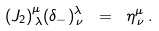<formula> <loc_0><loc_0><loc_500><loc_500>( J _ { 2 } ) ^ { \mu } _ { \, \lambda } ( \delta _ { - } ) ^ { \lambda } _ { \, \nu } \ = \ \eta ^ { \mu } _ { \, \nu } \, .</formula> 